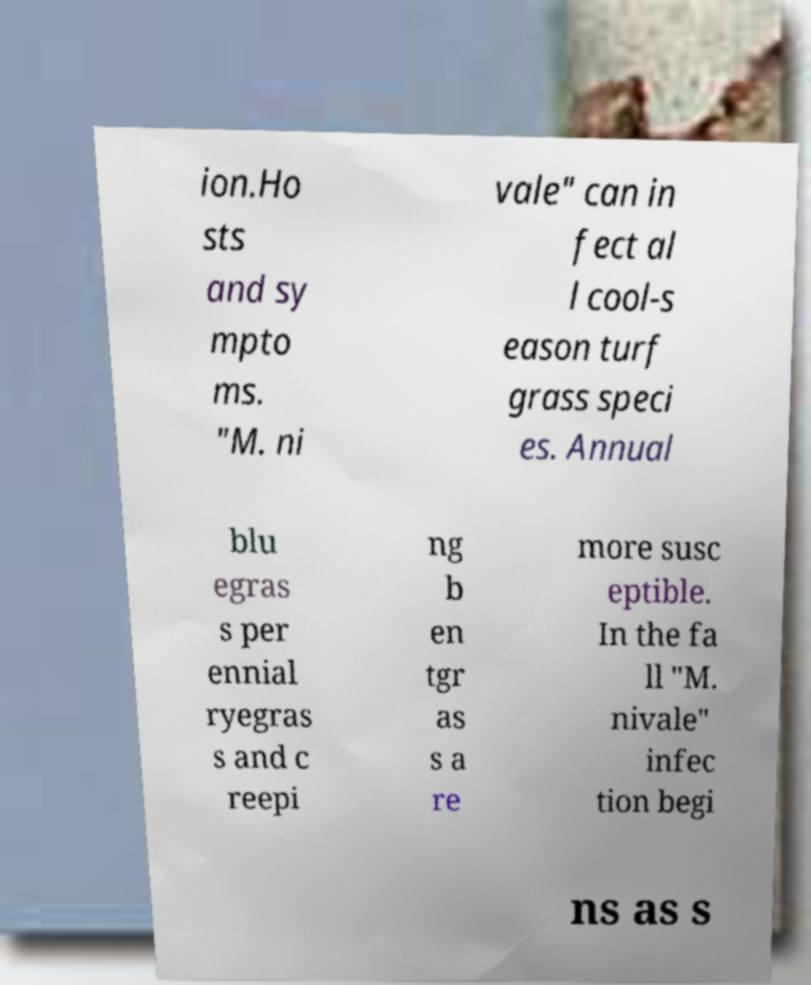There's text embedded in this image that I need extracted. Can you transcribe it verbatim? ion.Ho sts and sy mpto ms. "M. ni vale" can in fect al l cool-s eason turf grass speci es. Annual blu egras s per ennial ryegras s and c reepi ng b en tgr as s a re more susc eptible. In the fa ll "M. nivale" infec tion begi ns as s 